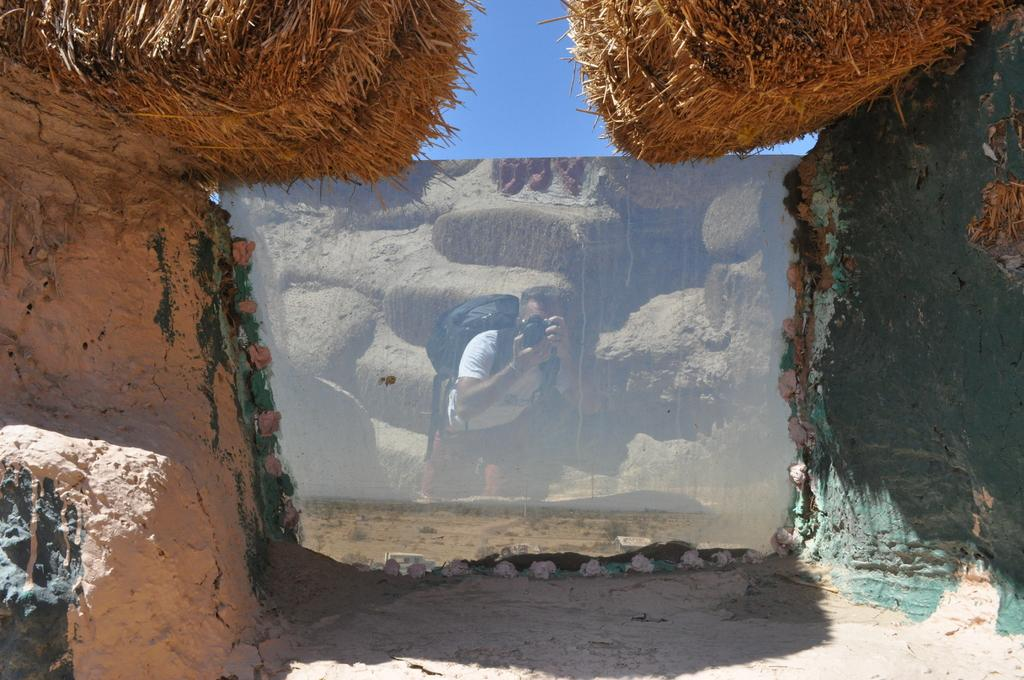What can be seen in the foreground of the image? In the foreground of the image, there are rocks, dry grass, and a mirror-like object. What is the purpose of the mirror-like object in the image? The reflection of a person holding a camera is visible in the mirror-like object. What type of vegetation is present in the foreground of the image? Dry grass is present in the foreground of the image. What is visible at the top of the image? The sky is visible at the top of the image. What type of bait is being used by the carpenter in the image? There is no carpenter or bait present in the image. What type of poison is visible in the reflection of the mirror-like object? There is no poison visible in the image, only the reflection of a person holding a camera. 